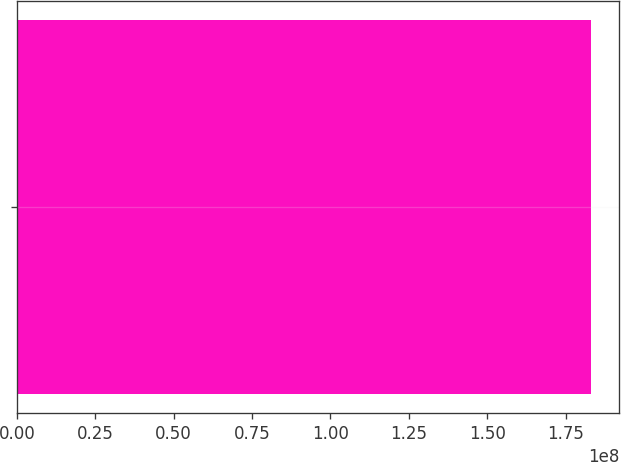<chart> <loc_0><loc_0><loc_500><loc_500><bar_chart><ecel><nl><fcel>1.82971e+08<nl></chart> 